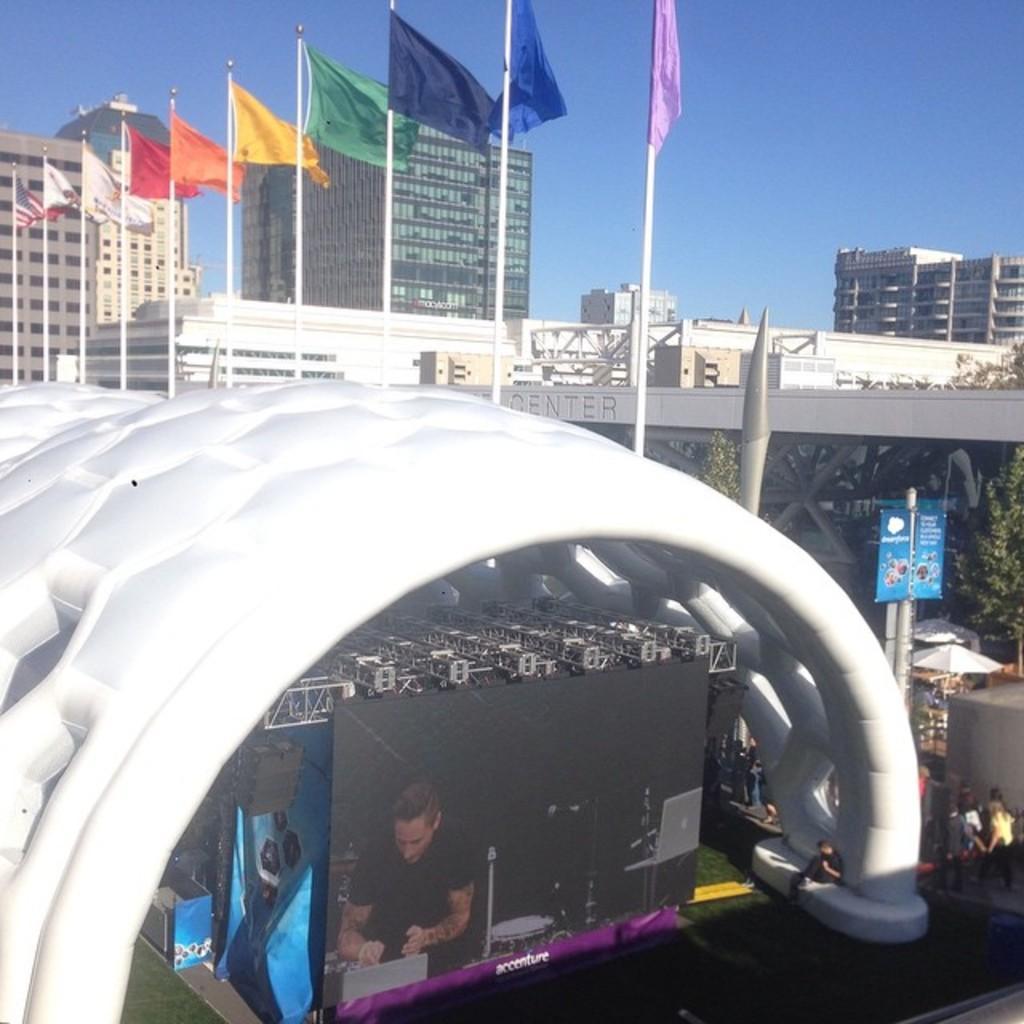In one or two sentences, can you explain what this image depicts? In this image we can see buildings, flags to the flag posts, trees, information boards, parasols, persons standing on the road, display screen, iron grills and sky. 